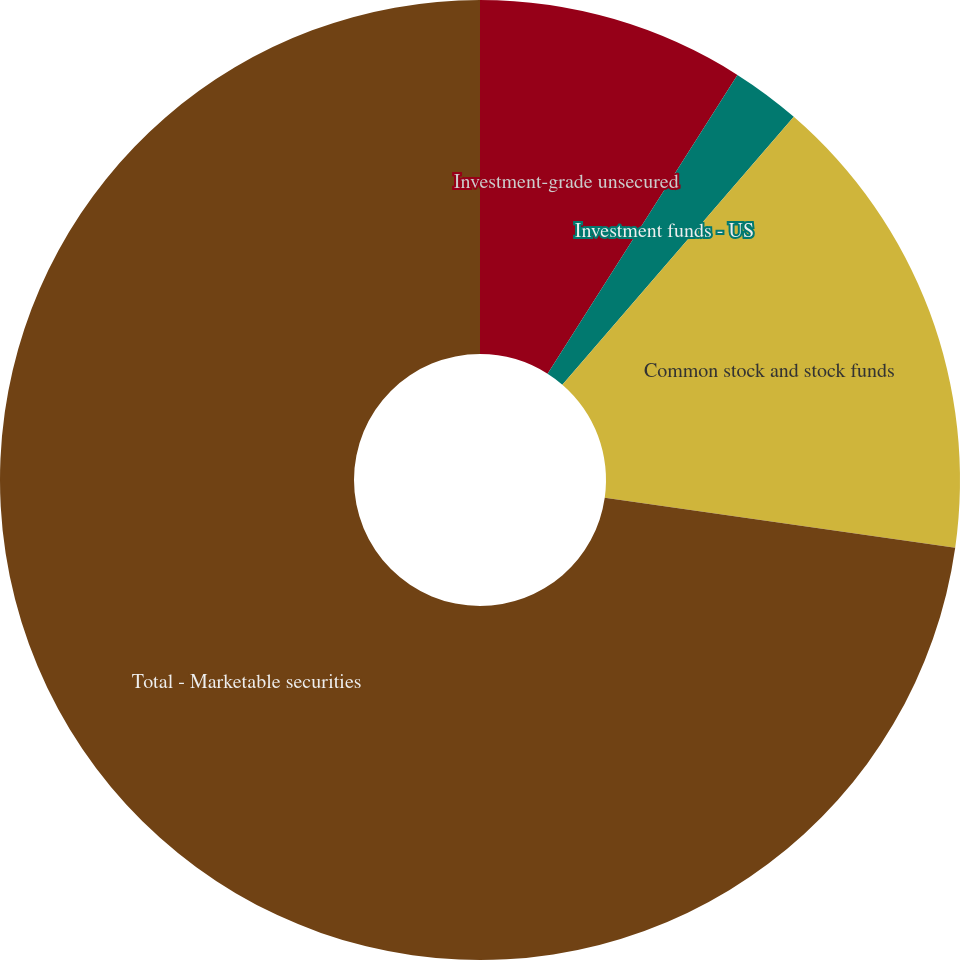Convert chart to OTSL. <chart><loc_0><loc_0><loc_500><loc_500><pie_chart><fcel>Investment-grade unsecured<fcel>Investment funds - US<fcel>Common stock and stock funds<fcel>Total - Marketable securities<nl><fcel>9.01%<fcel>2.33%<fcel>15.91%<fcel>72.75%<nl></chart> 